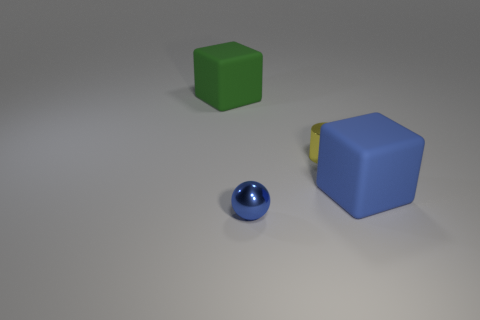How many things are either tiny green metallic things or blue spheres?
Offer a terse response. 1. There is a metal sphere on the left side of the small cylinder; is it the same size as the rubber block in front of the yellow shiny cylinder?
Keep it short and to the point. No. Are there any large shiny objects that have the same shape as the green matte thing?
Provide a succinct answer. No. Is the number of big objects behind the small yellow metallic cylinder less than the number of large objects?
Your response must be concise. Yes. Is the green rubber object the same shape as the large blue thing?
Offer a terse response. Yes. What is the size of the cube to the right of the small metallic ball?
Give a very brief answer. Large. There is a object that is made of the same material as the yellow cylinder; what is its size?
Your answer should be very brief. Small. Are there fewer blue spheres than small cyan rubber cylinders?
Keep it short and to the point. No. There is a blue object that is the same size as the green thing; what is it made of?
Your answer should be compact. Rubber. Is the number of big rubber objects greater than the number of green cylinders?
Your response must be concise. Yes. 